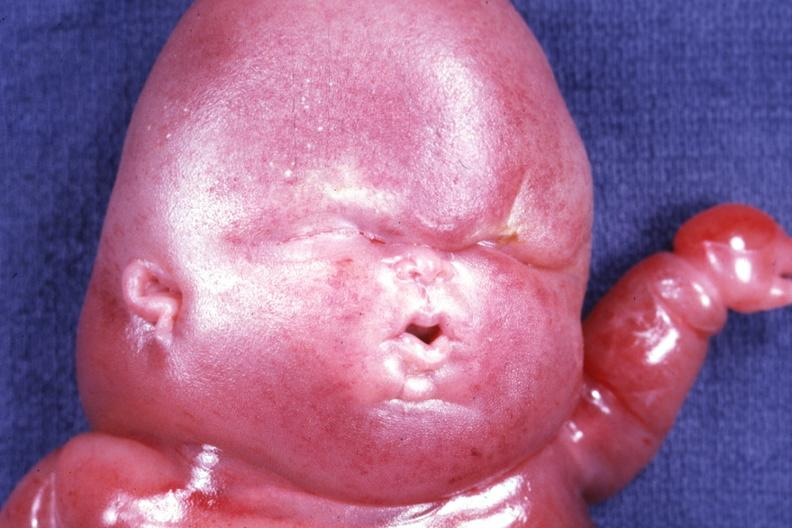does this image show mostly head in photo gory edema?
Answer the question using a single word or phrase. Yes 